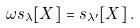<formula> <loc_0><loc_0><loc_500><loc_500>\omega s _ { \lambda } [ X ] = s _ { \lambda ^ { \prime } } [ X ] \, .</formula> 